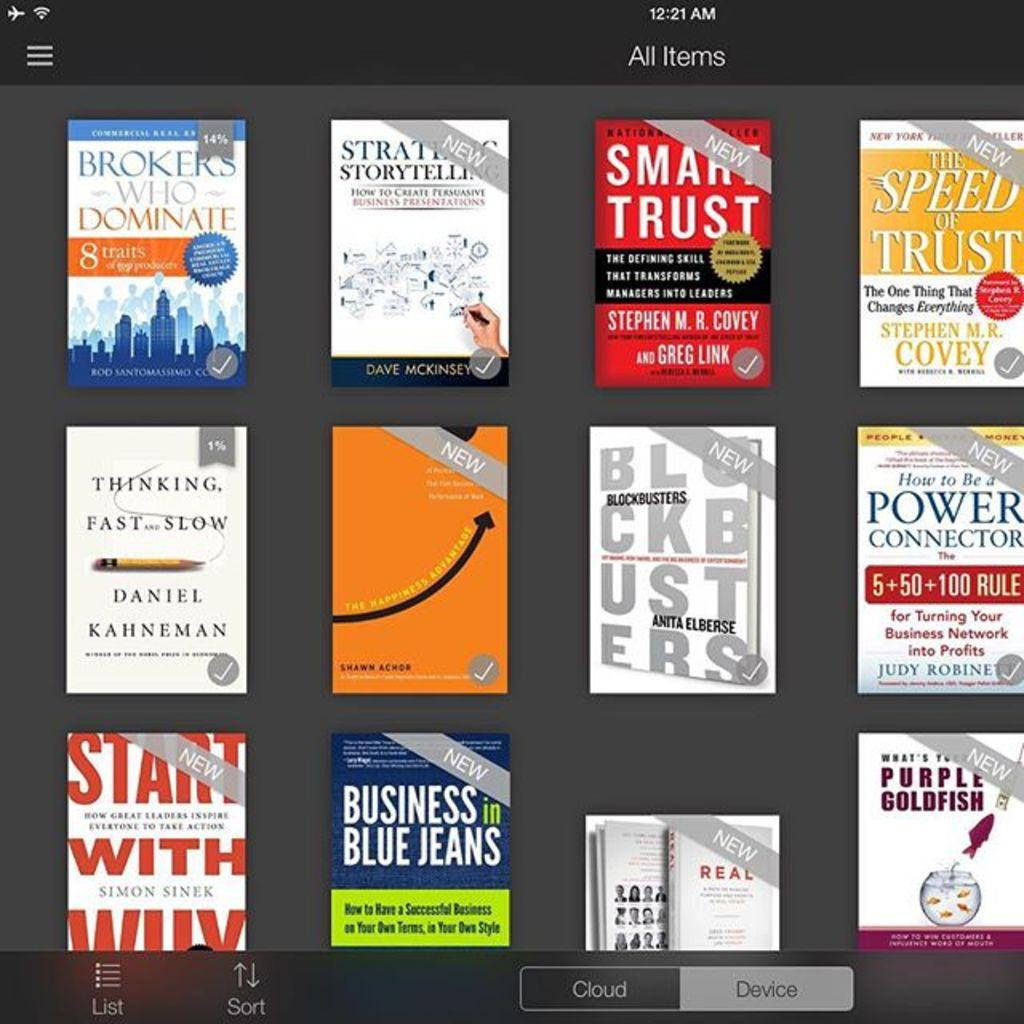<image>
Summarize the visual content of the image. A reading app shows that this person has Smart Trust and Blockbusters available to read. 